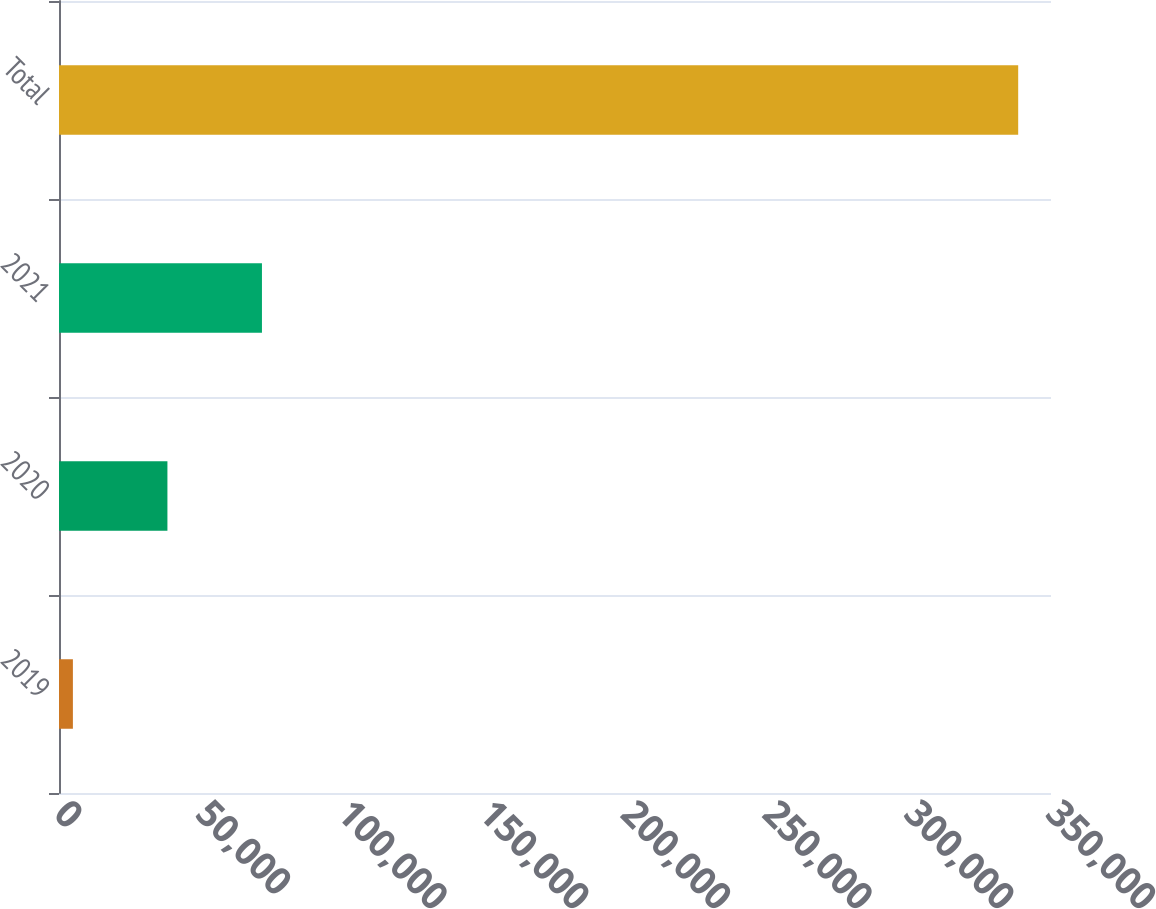Convert chart. <chart><loc_0><loc_0><loc_500><loc_500><bar_chart><fcel>2019<fcel>2020<fcel>2021<fcel>Total<nl><fcel>4901<fcel>38253.2<fcel>71605.4<fcel>338423<nl></chart> 